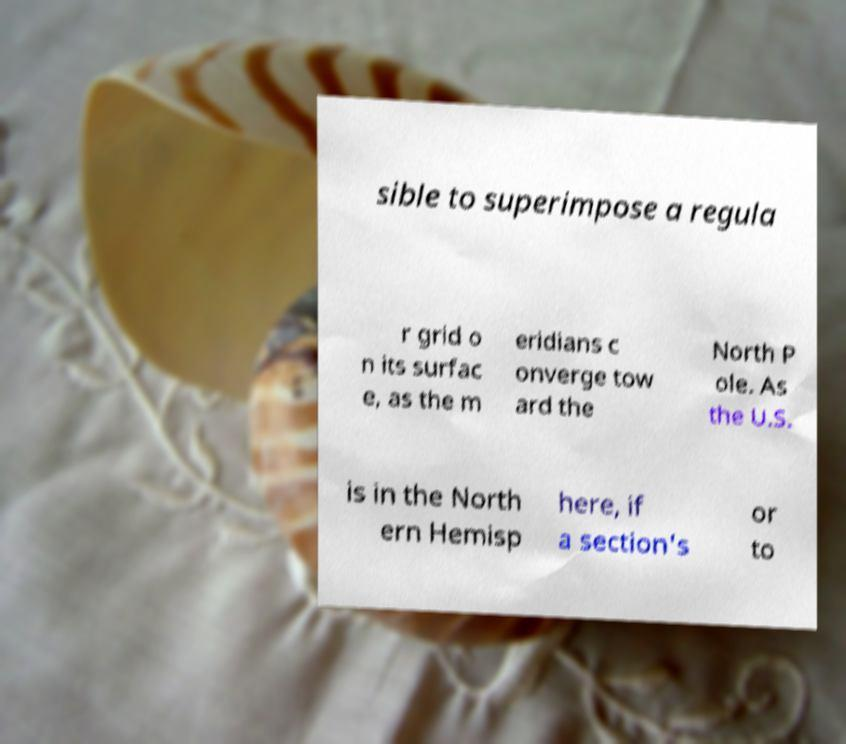I need the written content from this picture converted into text. Can you do that? sible to superimpose a regula r grid o n its surfac e, as the m eridians c onverge tow ard the North P ole. As the U.S. is in the North ern Hemisp here, if a section's or to 